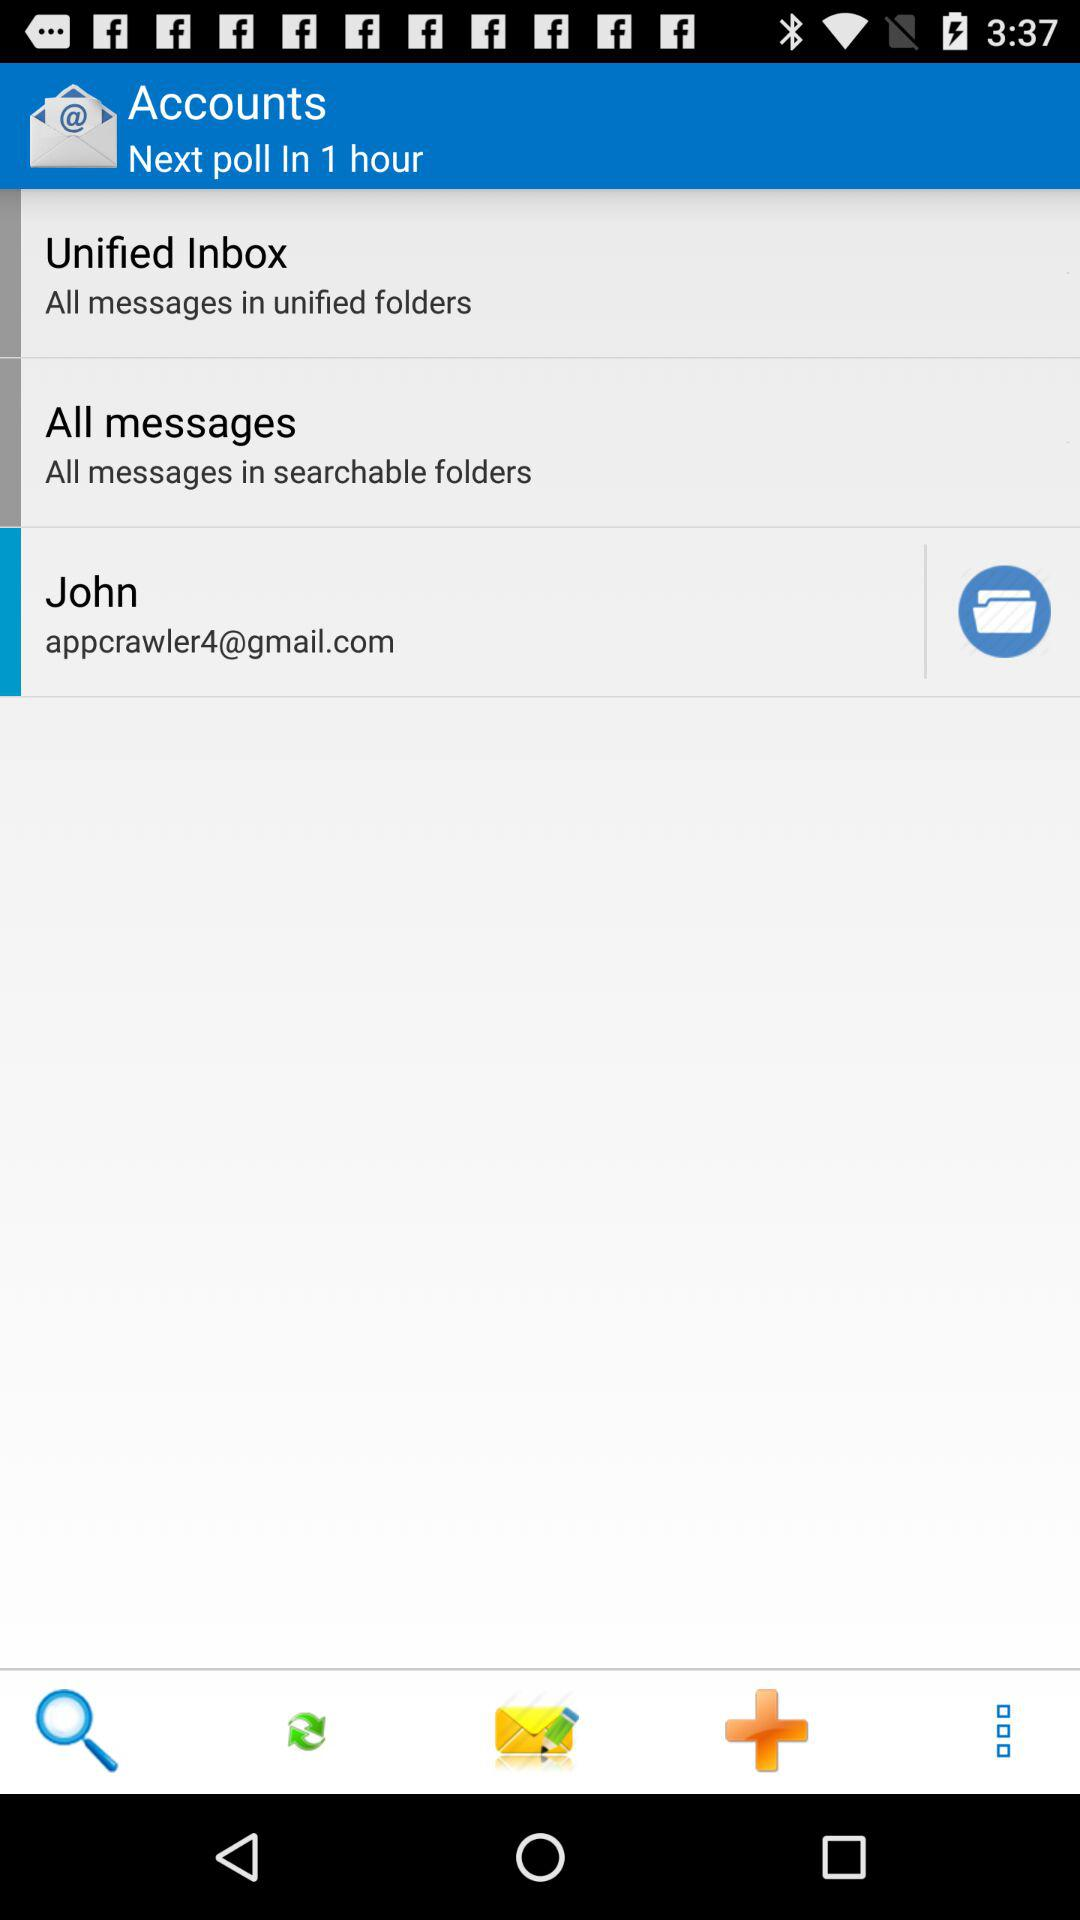What is the email address? The email address is appcrawler4@gmail.com. 